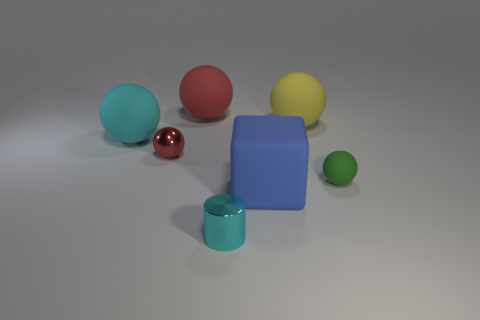Subtract all gray balls. Subtract all red cylinders. How many balls are left? 5 Add 1 large cyan things. How many objects exist? 8 Subtract all balls. How many objects are left? 2 Add 3 large blue rubber things. How many large blue rubber things exist? 4 Subtract 1 cyan spheres. How many objects are left? 6 Subtract all large blue things. Subtract all tiny green matte cylinders. How many objects are left? 6 Add 2 tiny green rubber balls. How many tiny green rubber balls are left? 3 